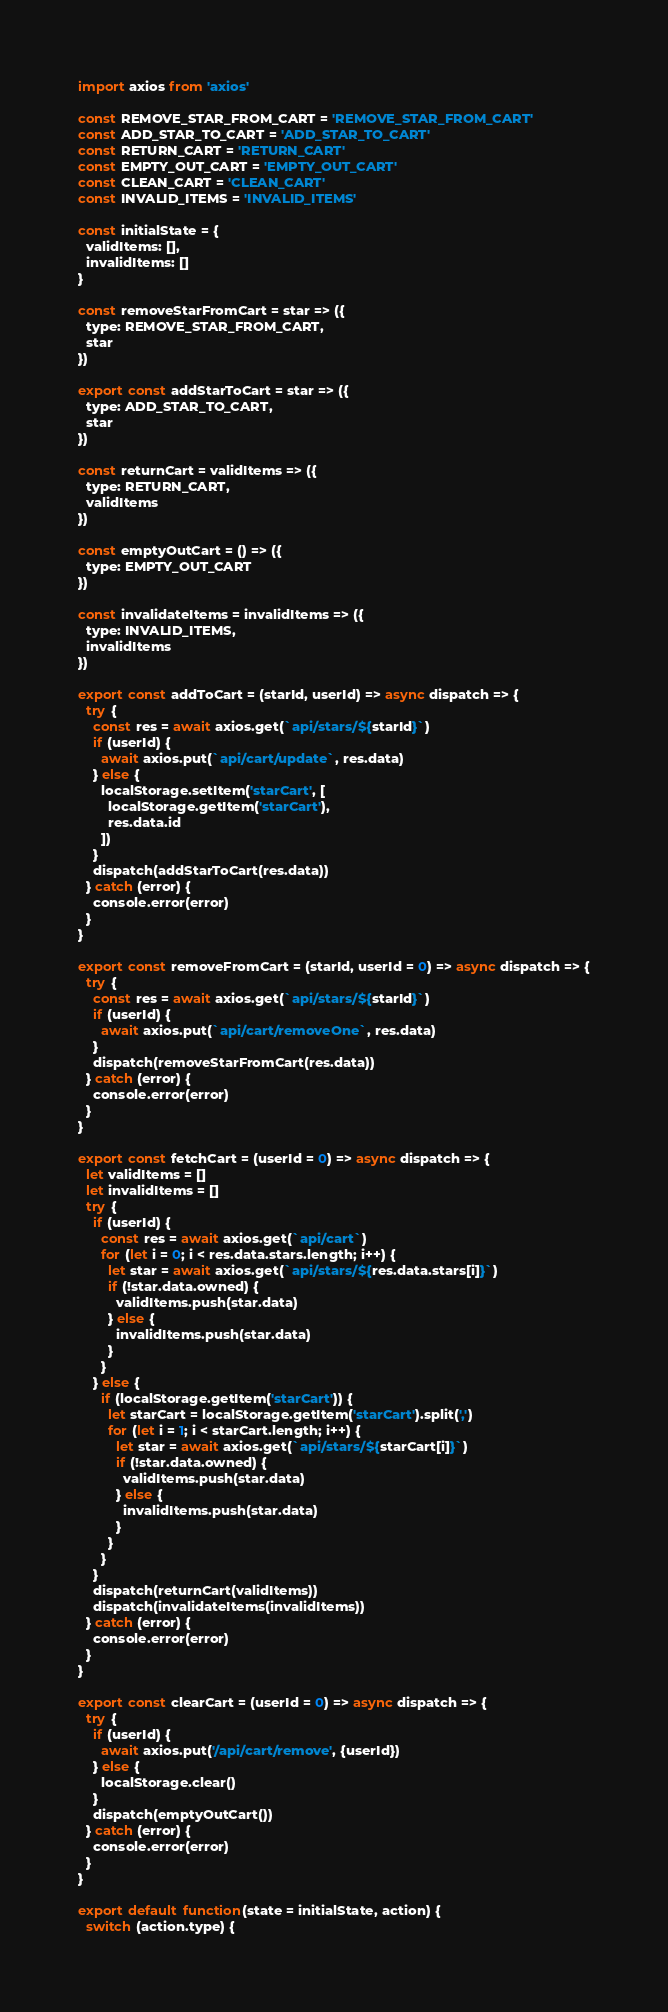Convert code to text. <code><loc_0><loc_0><loc_500><loc_500><_JavaScript_>import axios from 'axios'

const REMOVE_STAR_FROM_CART = 'REMOVE_STAR_FROM_CART'
const ADD_STAR_TO_CART = 'ADD_STAR_TO_CART'
const RETURN_CART = 'RETURN_CART'
const EMPTY_OUT_CART = 'EMPTY_OUT_CART'
const CLEAN_CART = 'CLEAN_CART'
const INVALID_ITEMS = 'INVALID_ITEMS'

const initialState = {
  validItems: [],
  invalidItems: []
}

const removeStarFromCart = star => ({
  type: REMOVE_STAR_FROM_CART,
  star
})

export const addStarToCart = star => ({
  type: ADD_STAR_TO_CART,
  star
})

const returnCart = validItems => ({
  type: RETURN_CART,
  validItems
})

const emptyOutCart = () => ({
  type: EMPTY_OUT_CART
})

const invalidateItems = invalidItems => ({
  type: INVALID_ITEMS,
  invalidItems
})

export const addToCart = (starId, userId) => async dispatch => {
  try {
    const res = await axios.get(`api/stars/${starId}`)
    if (userId) {
      await axios.put(`api/cart/update`, res.data)
    } else {
      localStorage.setItem('starCart', [
        localStorage.getItem('starCart'),
        res.data.id
      ])
    }
    dispatch(addStarToCart(res.data))
  } catch (error) {
    console.error(error)
  }
}

export const removeFromCart = (starId, userId = 0) => async dispatch => {
  try {
    const res = await axios.get(`api/stars/${starId}`)
    if (userId) {
      await axios.put(`api/cart/removeOne`, res.data)
    }
    dispatch(removeStarFromCart(res.data))
  } catch (error) {
    console.error(error)
  }
}

export const fetchCart = (userId = 0) => async dispatch => {
  let validItems = []
  let invalidItems = []
  try {
    if (userId) {
      const res = await axios.get(`api/cart`)
      for (let i = 0; i < res.data.stars.length; i++) {
        let star = await axios.get(`api/stars/${res.data.stars[i]}`)
        if (!star.data.owned) {
          validItems.push(star.data)
        } else {
          invalidItems.push(star.data)
        }
      }
    } else {
      if (localStorage.getItem('starCart')) {
        let starCart = localStorage.getItem('starCart').split(',')
        for (let i = 1; i < starCart.length; i++) {
          let star = await axios.get(`api/stars/${starCart[i]}`)
          if (!star.data.owned) {
            validItems.push(star.data)
          } else {
            invalidItems.push(star.data)
          }
        }
      }
    }
    dispatch(returnCart(validItems))
    dispatch(invalidateItems(invalidItems))
  } catch (error) {
    console.error(error)
  }
}

export const clearCart = (userId = 0) => async dispatch => {
  try {
    if (userId) {
      await axios.put('/api/cart/remove', {userId})
    } else {
      localStorage.clear()
    }
    dispatch(emptyOutCart())
  } catch (error) {
    console.error(error)
  }
}

export default function(state = initialState, action) {
  switch (action.type) {</code> 